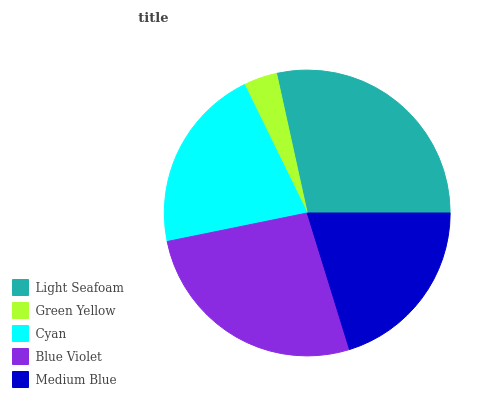Is Green Yellow the minimum?
Answer yes or no. Yes. Is Light Seafoam the maximum?
Answer yes or no. Yes. Is Cyan the minimum?
Answer yes or no. No. Is Cyan the maximum?
Answer yes or no. No. Is Cyan greater than Green Yellow?
Answer yes or no. Yes. Is Green Yellow less than Cyan?
Answer yes or no. Yes. Is Green Yellow greater than Cyan?
Answer yes or no. No. Is Cyan less than Green Yellow?
Answer yes or no. No. Is Cyan the high median?
Answer yes or no. Yes. Is Cyan the low median?
Answer yes or no. Yes. Is Green Yellow the high median?
Answer yes or no. No. Is Medium Blue the low median?
Answer yes or no. No. 